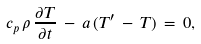Convert formula to latex. <formula><loc_0><loc_0><loc_500><loc_500>c _ { p } \, \rho \, \frac { \partial T } { \partial t } \, - \, a \, ( T ^ { \prime } \, - \, T ) \, = \, 0 ,</formula> 